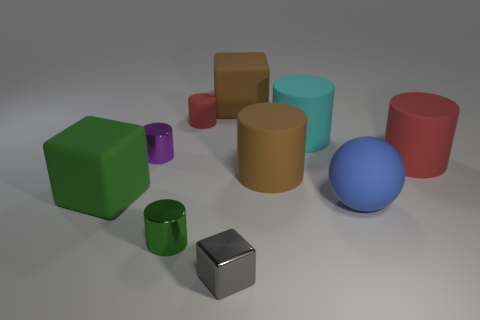Subtract all big brown cylinders. How many cylinders are left? 5 Subtract all red cylinders. How many cylinders are left? 4 Subtract all cylinders. How many objects are left? 4 Subtract all gray cubes. How many red cylinders are left? 2 Subtract 2 cylinders. How many cylinders are left? 4 Add 1 big rubber cylinders. How many big rubber cylinders are left? 4 Add 7 red cylinders. How many red cylinders exist? 9 Subtract 0 gray balls. How many objects are left? 10 Subtract all brown cylinders. Subtract all gray balls. How many cylinders are left? 5 Subtract all red cylinders. Subtract all rubber balls. How many objects are left? 7 